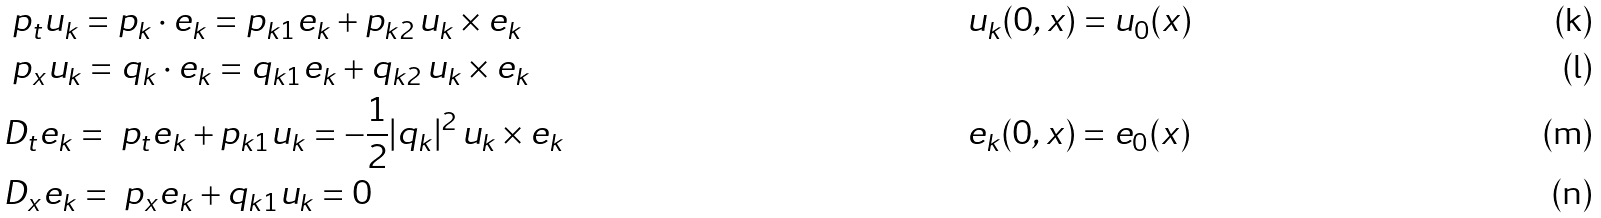<formula> <loc_0><loc_0><loc_500><loc_500>& \ p _ { t } u _ { k } = p _ { k } \cdot e _ { k } = p _ { k 1 } e _ { k } + p _ { k 2 } \, u _ { k } \times e _ { k } \quad & & u _ { k } ( 0 , x ) = u _ { 0 } ( x ) \\ & \ p _ { x } u _ { k } = q _ { k } \cdot e _ { k } = q _ { k 1 } e _ { k } + q _ { k 2 } \, u _ { k } \times e _ { k } \\ & D _ { t } e _ { k } = \ p _ { t } e _ { k } + p _ { k 1 } u _ { k } = - \frac { 1 } { 2 } { | q _ { k } | ^ { 2 } } \, u _ { k } \times e _ { k } & & e _ { k } ( 0 , x ) = e _ { 0 } ( x ) \\ & D _ { x } e _ { k } = \ p _ { x } e _ { k } + q _ { k 1 } u _ { k } = 0</formula> 